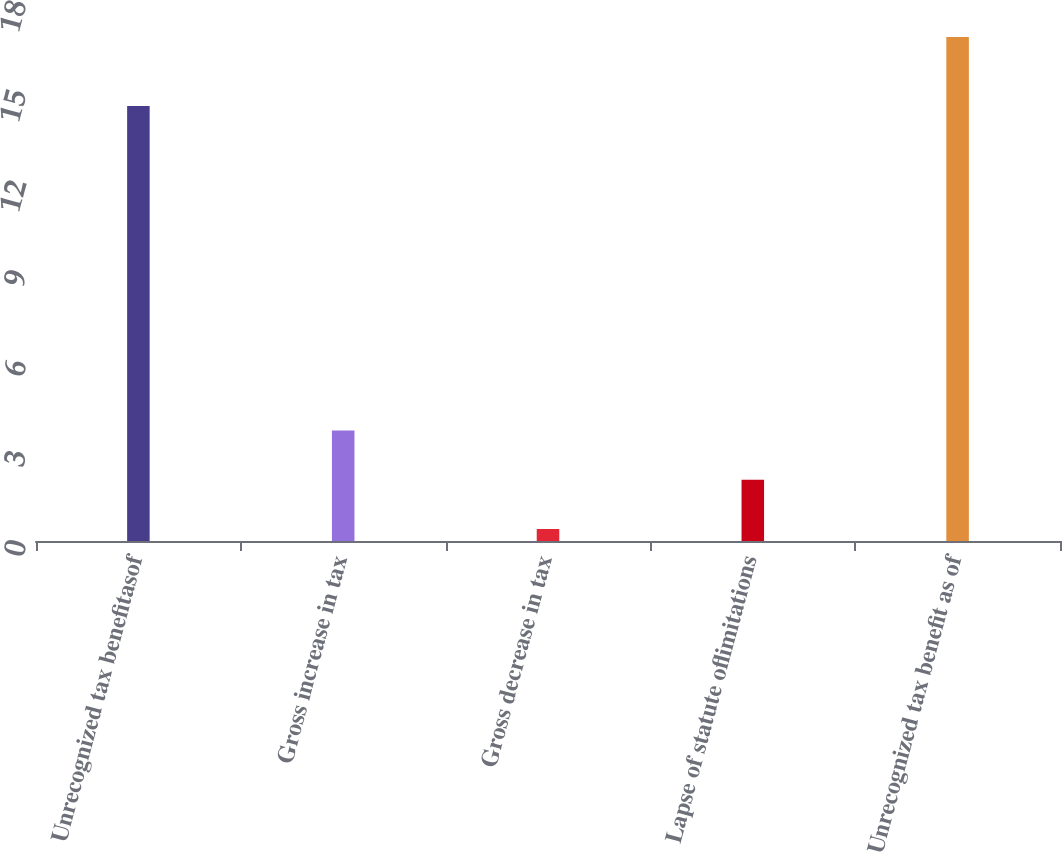Convert chart. <chart><loc_0><loc_0><loc_500><loc_500><bar_chart><fcel>Unrecognized tax benefitasof<fcel>Gross increase in tax<fcel>Gross decrease in tax<fcel>Lapse of statute oflimitations<fcel>Unrecognized tax benefit as of<nl><fcel>14.5<fcel>3.68<fcel>0.4<fcel>2.04<fcel>16.8<nl></chart> 